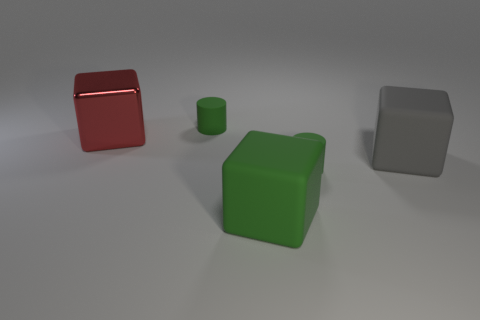Add 3 big shiny cubes. How many objects exist? 8 Subtract all cylinders. How many objects are left? 3 Add 4 large gray matte cubes. How many large gray matte cubes are left? 5 Add 1 tiny green cubes. How many tiny green cubes exist? 1 Subtract 0 cyan balls. How many objects are left? 5 Subtract all tiny green rubber objects. Subtract all small green matte cylinders. How many objects are left? 1 